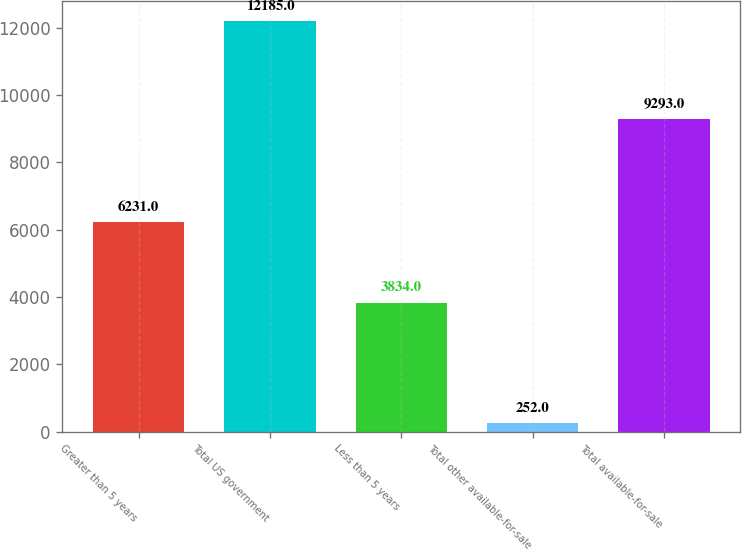<chart> <loc_0><loc_0><loc_500><loc_500><bar_chart><fcel>Greater than 5 years<fcel>Total US government<fcel>Less than 5 years<fcel>Total other available-for-sale<fcel>Total available-for-sale<nl><fcel>6231<fcel>12185<fcel>3834<fcel>252<fcel>9293<nl></chart> 